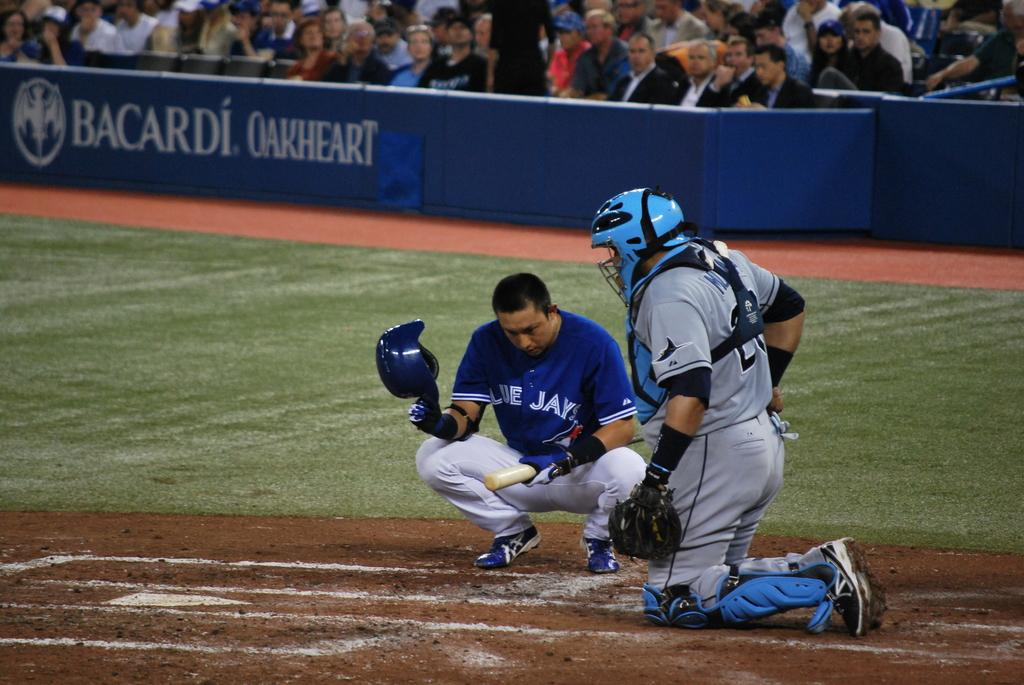<image>
Relay a brief, clear account of the picture shown. The batter for the Blue Jays squats down near a Bacardi Oakheart advertisement. 